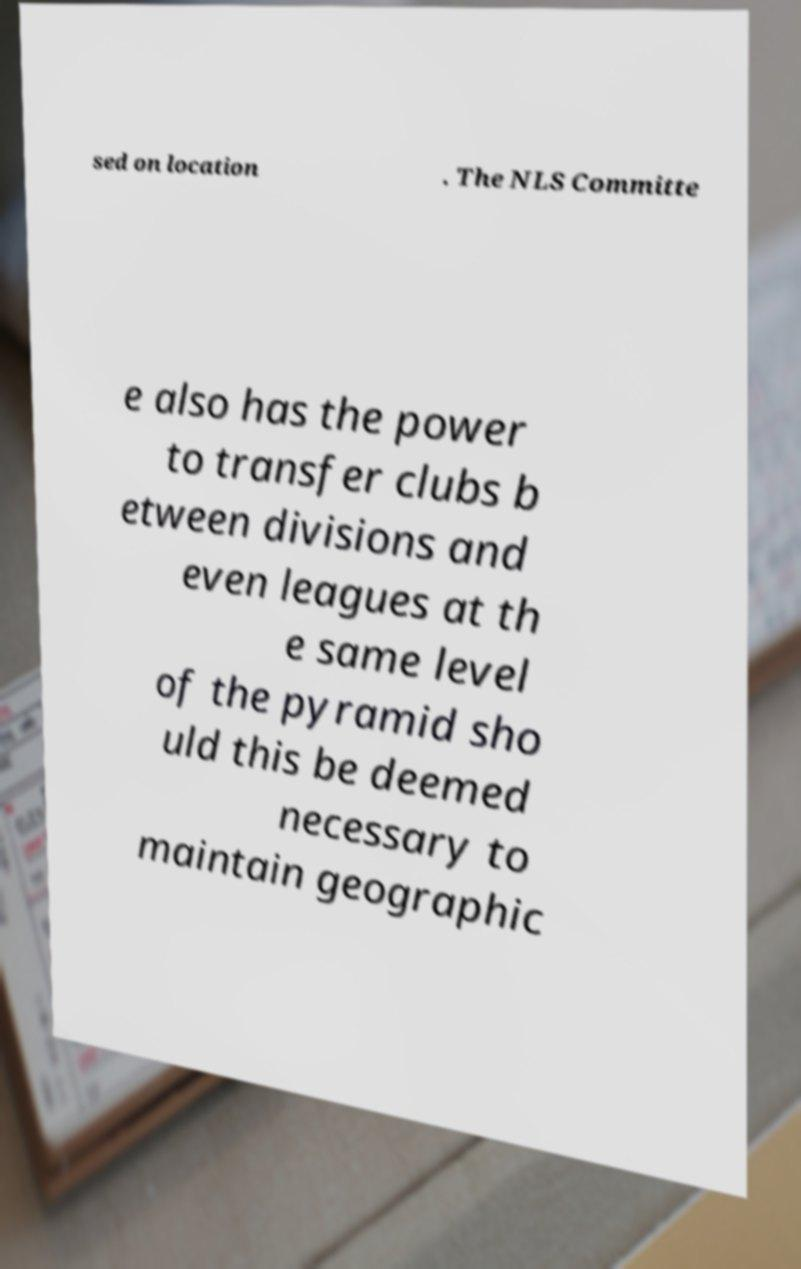I need the written content from this picture converted into text. Can you do that? sed on location . The NLS Committe e also has the power to transfer clubs b etween divisions and even leagues at th e same level of the pyramid sho uld this be deemed necessary to maintain geographic 